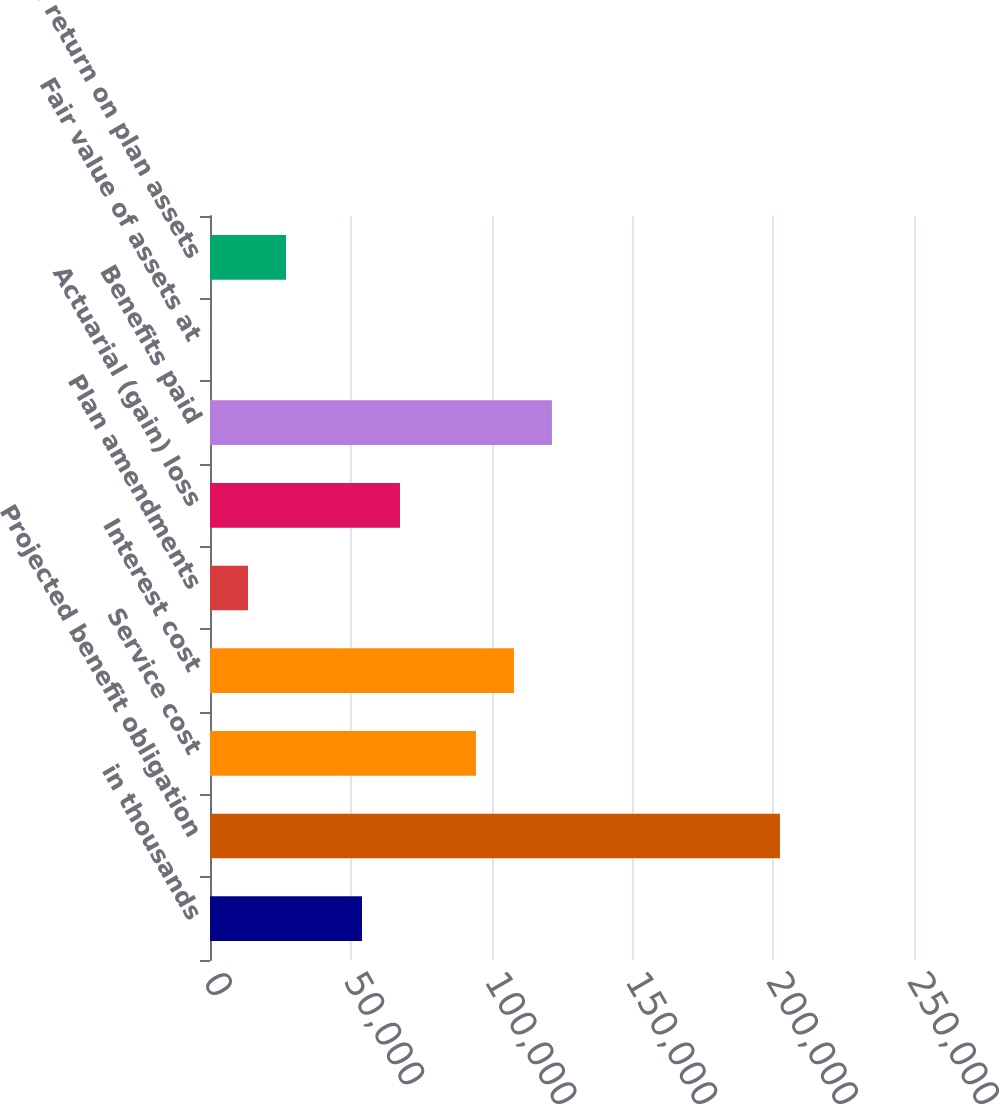Convert chart to OTSL. <chart><loc_0><loc_0><loc_500><loc_500><bar_chart><fcel>in thousands<fcel>Projected benefit obligation<fcel>Service cost<fcel>Interest cost<fcel>Plan amendments<fcel>Actuarial (gain) loss<fcel>Benefits paid<fcel>Fair value of assets at<fcel>Actual return on plan assets<nl><fcel>53970.7<fcel>202389<fcel>94448.4<fcel>107941<fcel>13493<fcel>67463.2<fcel>121433<fcel>0.45<fcel>26985.6<nl></chart> 